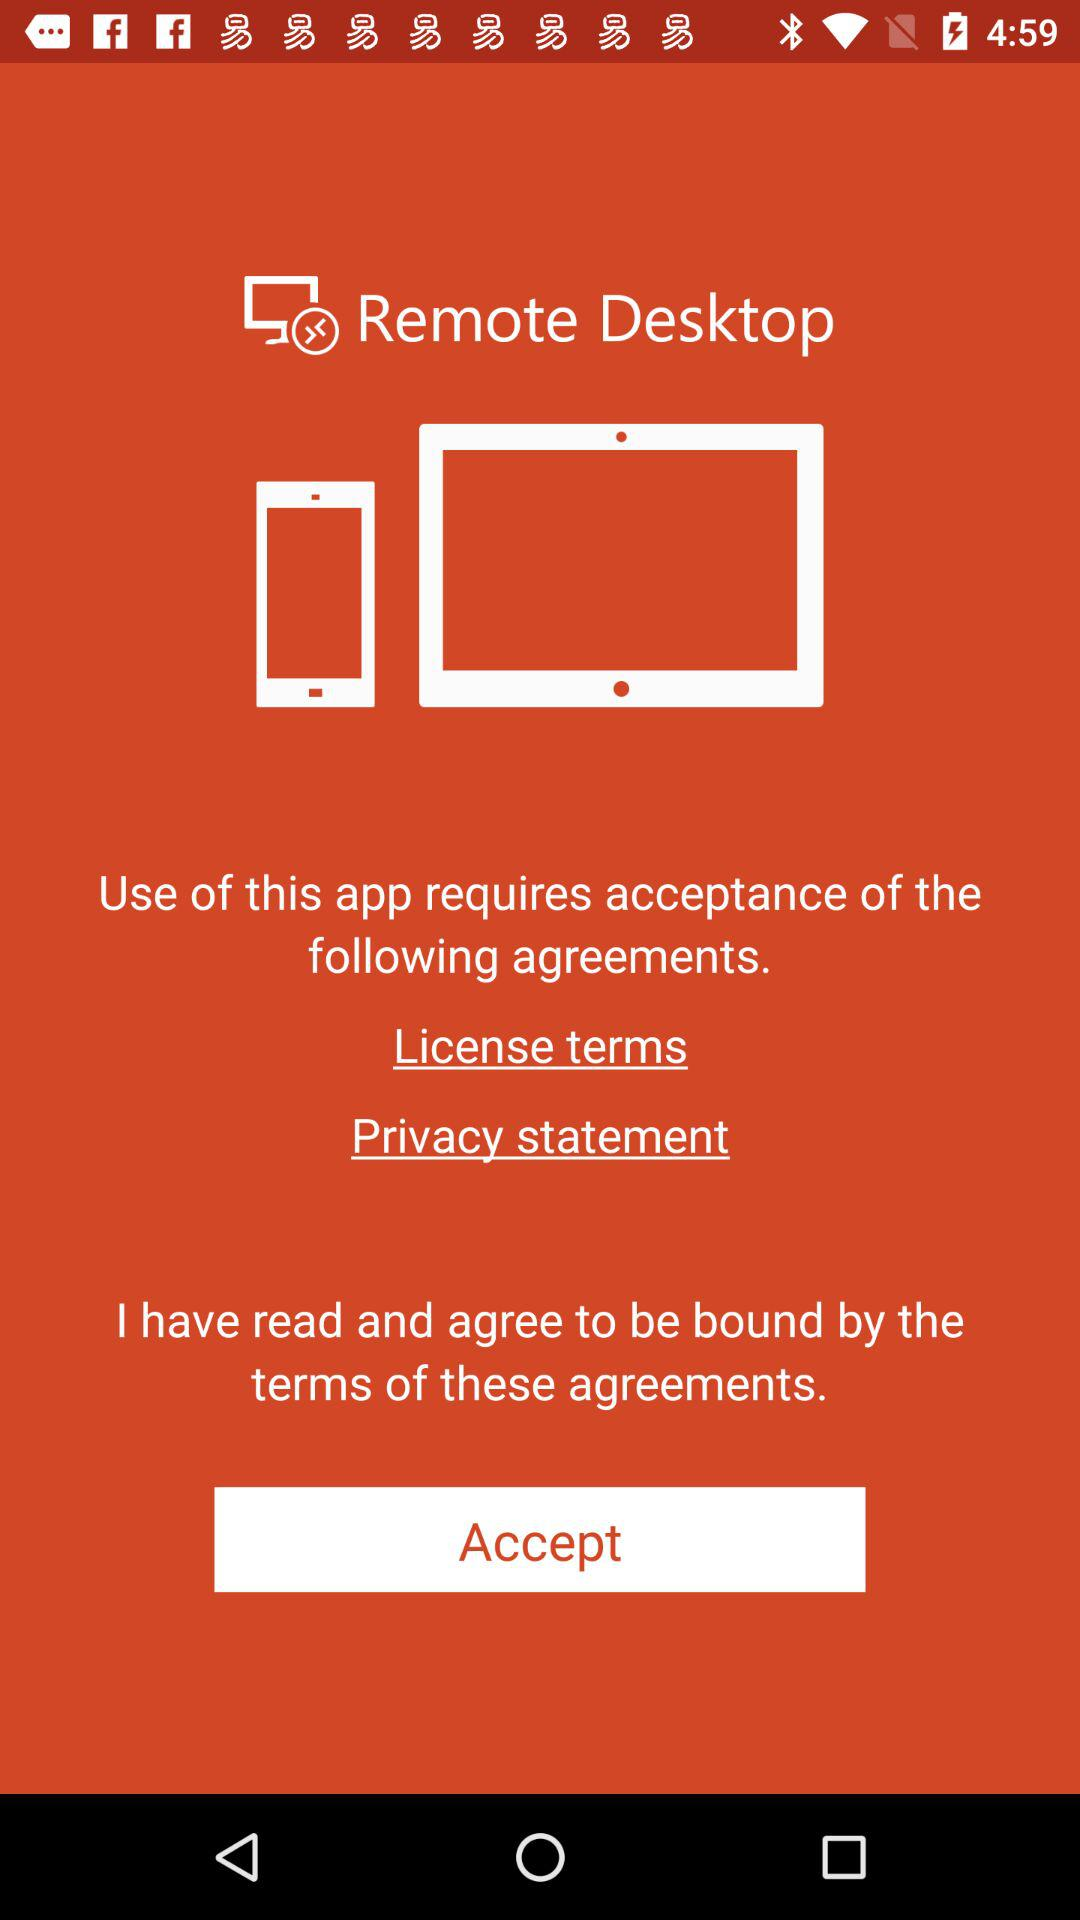How many agreements must you accept to use the app?
Answer the question using a single word or phrase. 2 